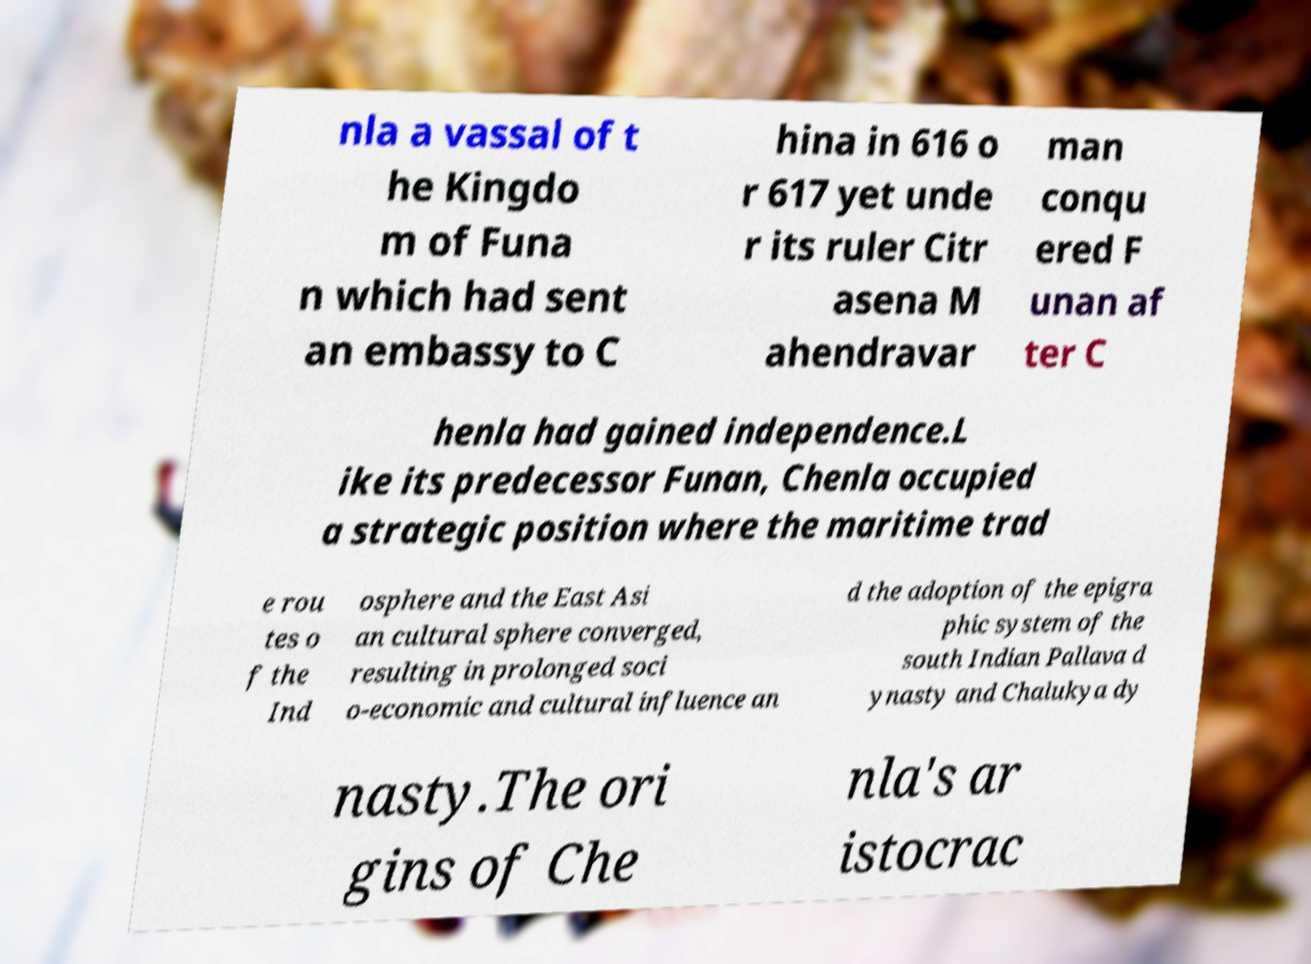Could you assist in decoding the text presented in this image and type it out clearly? nla a vassal of t he Kingdo m of Funa n which had sent an embassy to C hina in 616 o r 617 yet unde r its ruler Citr asena M ahendravar man conqu ered F unan af ter C henla had gained independence.L ike its predecessor Funan, Chenla occupied a strategic position where the maritime trad e rou tes o f the Ind osphere and the East Asi an cultural sphere converged, resulting in prolonged soci o-economic and cultural influence an d the adoption of the epigra phic system of the south Indian Pallava d ynasty and Chalukya dy nasty.The ori gins of Che nla's ar istocrac 